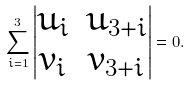<formula> <loc_0><loc_0><loc_500><loc_500>\sum _ { i = 1 } ^ { 3 } \begin{vmatrix} u _ { i } & u _ { 3 + i } \\ v _ { i } & v _ { 3 + i } \\ \end{vmatrix} = 0 .</formula> 